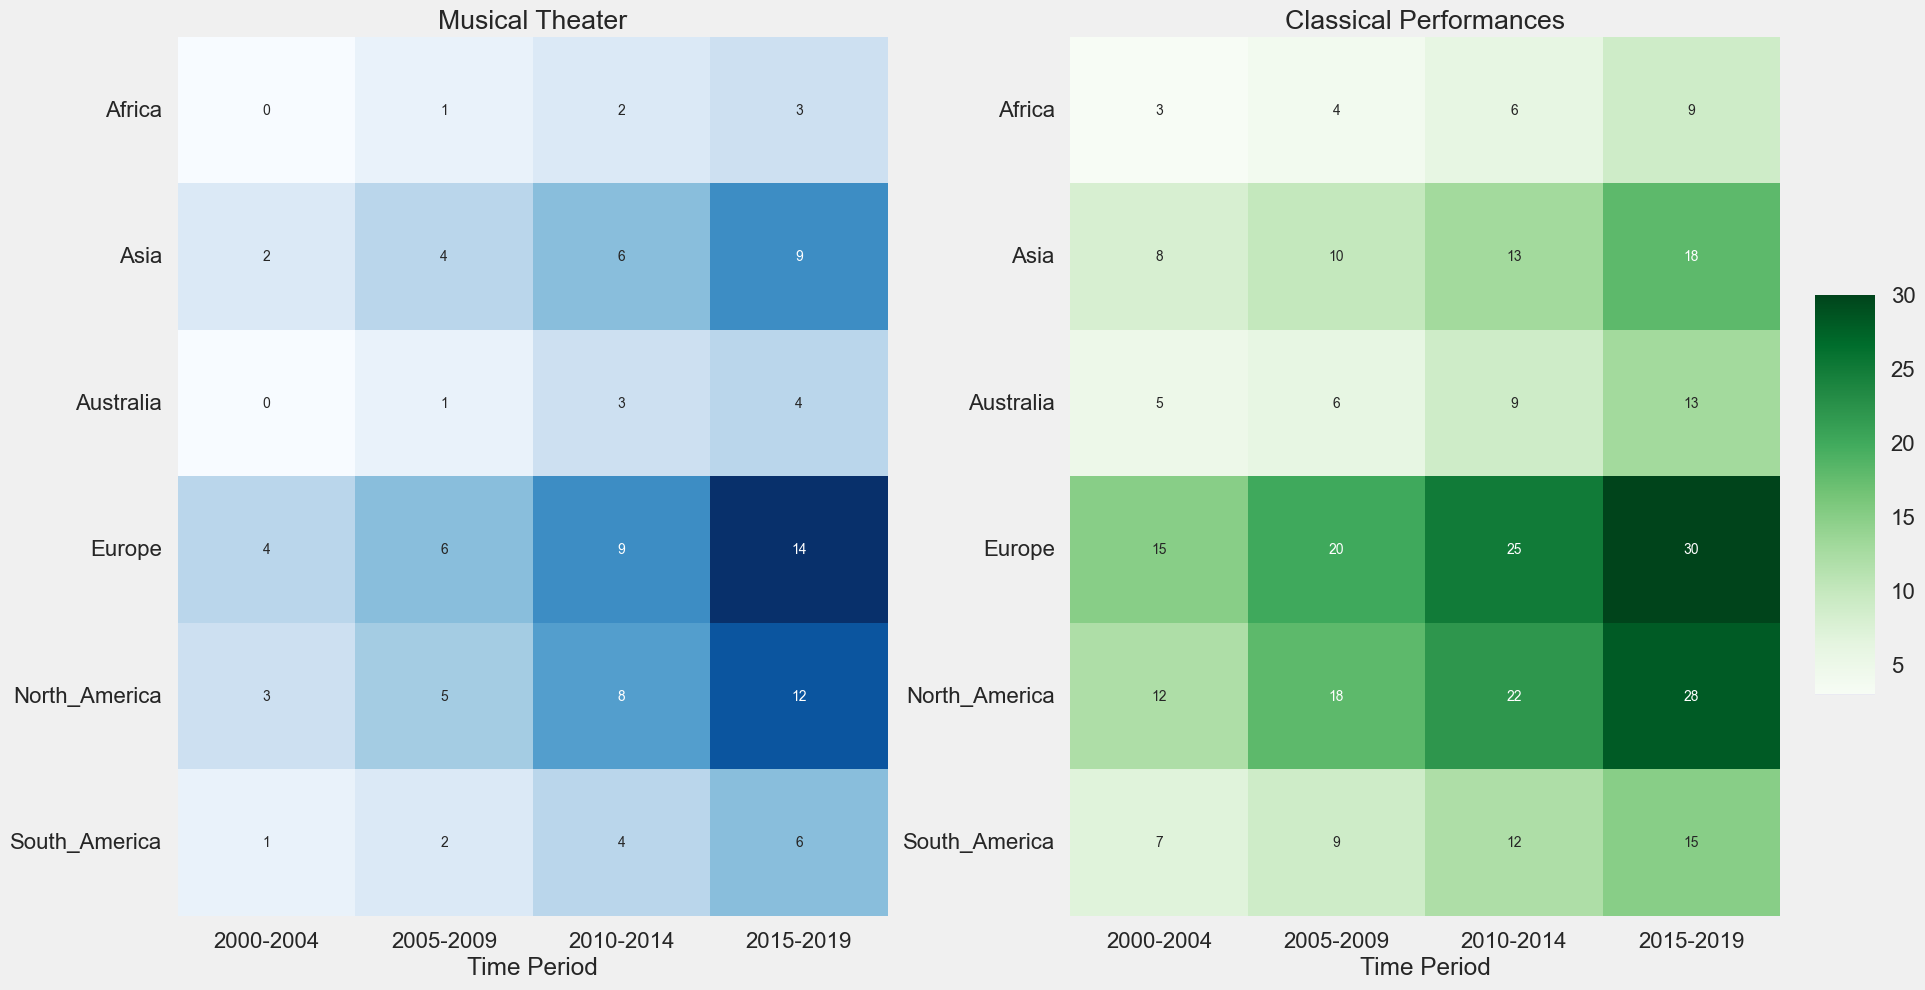Which region saw the greatest increase in the number of countertenor-inclusive musical theater productions from 2000-2004 to 2015-2019? First, identify the number of countertenor-inclusive musical theater productions in each region for 2000-2004 and 2015-2019. Calculate the difference for each region: North America (12-3=9), Europe (14-4=10), Asia (9-2=7), South America (6-1=5), Australia (4-0=4), Africa (3-0=3). The greatest increase is seen in Europe.
Answer: Europe Which region had the highest number of countertenor-inclusive classical performances from 2015 to 2019? Check the data for classical performances from 2015 to 2019. The numbers are: North America (28), Europe (30), Asia (18), South America (15), Australia (13), Africa (9). The highest number is in Europe.
Answer: Europe What's the total number of countertenor-inclusive classical performances in Asia over all the time periods? Sum the number of countertenor-inclusive classical performances in Asia for each time period: 8 (2000-2004) + 10 (2005-2009) + 13 (2010-2014) + 18 (2015-2019). This equals 49.
Answer: 49 Compare the number of countertenor-inclusive musical theater productions in North America and Europe during the period 2000-2004. Which region had more? For the period 2000-2004, North America had 3 and Europe had 4. Europe had more.
Answer: Europe Which region had the lowest increase in countertenor-inclusive classical performances from 2000-2004 to 2015-2019? Calculate the difference in countertenor-inclusive classical performances for each region from 2000-2004 to 2015-2019: North America (28-12=16), Europe (30-15=15), Asia (18-8=10), South America (15-7=8), Australia (13-5=8), Africa (9-3=6). The lowest increase is in Africa.
Answer: Africa How does the color intensity of the heatmap for musical theater productions change for South America from 2000 to 2019? Check the shades of blue for each period in South America. The sequence should show a gradual deepening of the color: from a very light blue (1, 2000-2004) to slightly darker (2, 2005-2009), mid-blue (4, 2010-2014), and somewhat dark blue (6, 2015-2019). The intensity increases steadily.
Answer: Increasing steadily What is the average number of countertenor-inclusive musical theater productions in Europe per time period? Calculate the sum of musical theater productions in Europe (4+6+9+14=33), then divide by the number of periods (4). The average is 33/4 = 8.25.
Answer: 8.25 Which region had the smallest number of countertenor-inclusive classical performances in 2000-2004, and what was that number? Check the data for classical performances in 2000-2004. The smallest number is in Africa with 3 performances.
Answer: Africa, 3 In which region and time period was the highest number of countertenor-inclusive musical theater productions recorded? Check all the cells in the musical theater heatmap to find the highest number, which is 14 in Europe during 2015-2019.
Answer: Europe, 2015-2019 